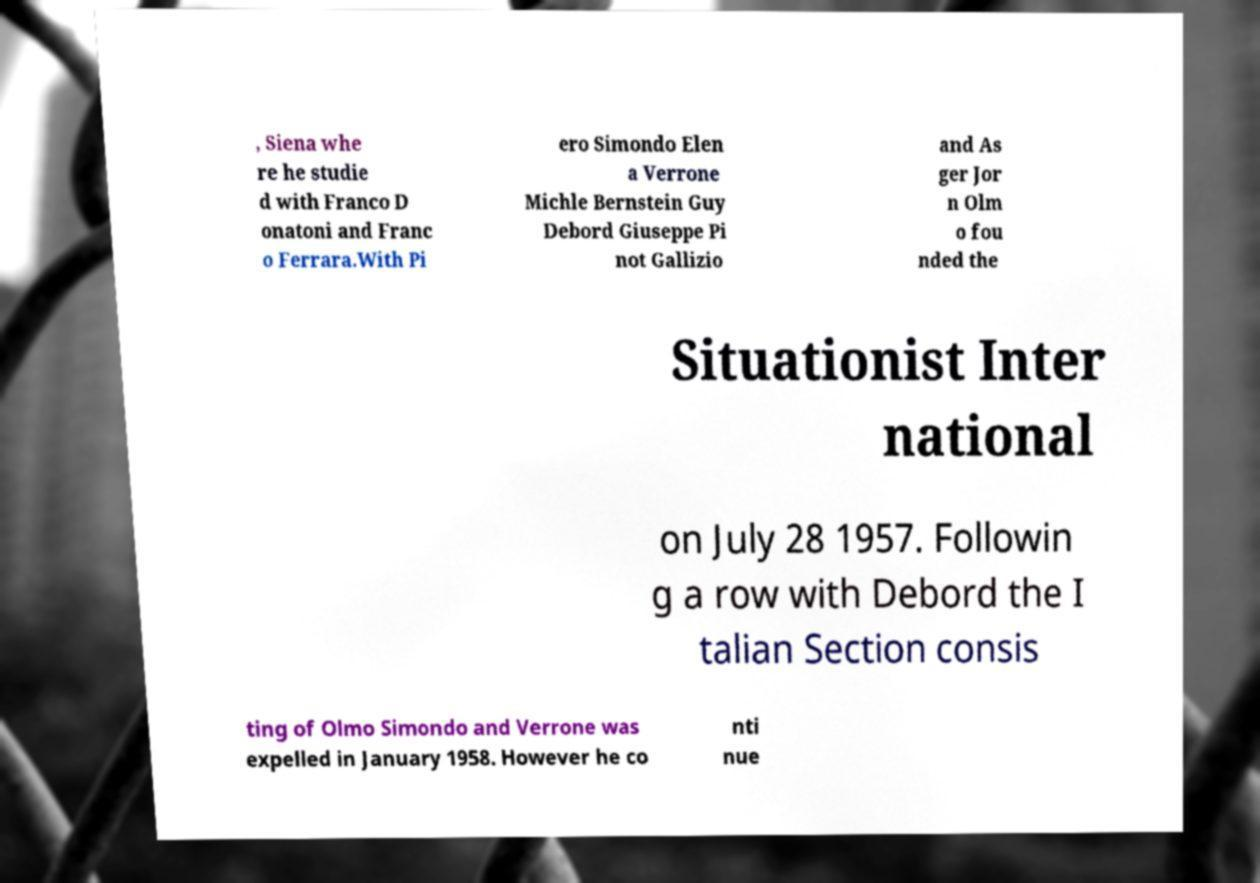Could you extract and type out the text from this image? , Siena whe re he studie d with Franco D onatoni and Franc o Ferrara.With Pi ero Simondo Elen a Verrone Michle Bernstein Guy Debord Giuseppe Pi not Gallizio and As ger Jor n Olm o fou nded the Situationist Inter national on July 28 1957. Followin g a row with Debord the I talian Section consis ting of Olmo Simondo and Verrone was expelled in January 1958. However he co nti nue 